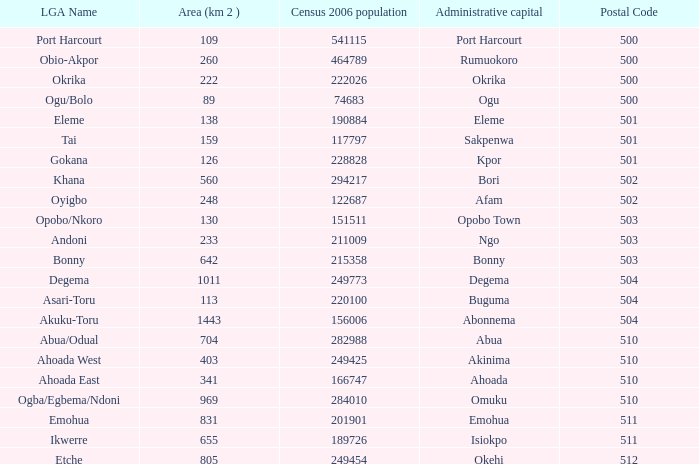What is the area when the Iga name is Ahoada East? 341.0. 